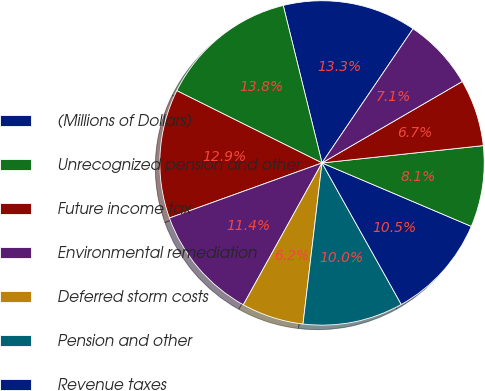Convert chart to OTSL. <chart><loc_0><loc_0><loc_500><loc_500><pie_chart><fcel>(Millions of Dollars)<fcel>Unrecognized pension and other<fcel>Future income tax<fcel>Environmental remediation<fcel>Deferred storm costs<fcel>Pension and other<fcel>Revenue taxes<fcel>Net electric deferrals<fcel>Unamortized loss on reacquired<fcel>Surcharge for New York State<nl><fcel>13.33%<fcel>13.81%<fcel>12.86%<fcel>11.43%<fcel>6.19%<fcel>10.0%<fcel>10.48%<fcel>8.1%<fcel>6.67%<fcel>7.14%<nl></chart> 